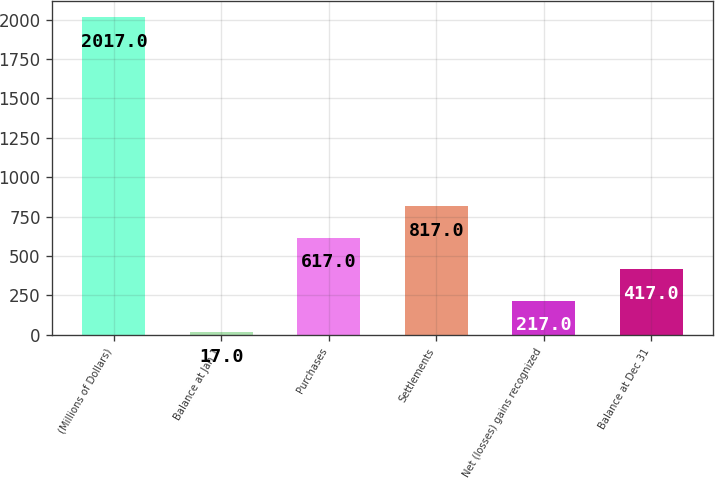<chart> <loc_0><loc_0><loc_500><loc_500><bar_chart><fcel>(Millions of Dollars)<fcel>Balance at Jan 1<fcel>Purchases<fcel>Settlements<fcel>Net (losses) gains recognized<fcel>Balance at Dec 31<nl><fcel>2017<fcel>17<fcel>617<fcel>817<fcel>217<fcel>417<nl></chart> 